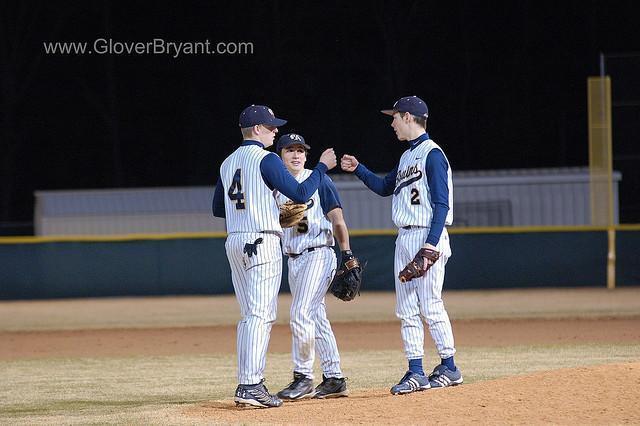How many people are there?
Give a very brief answer. 3. How many people are wearing orange glasses?
Give a very brief answer. 0. 